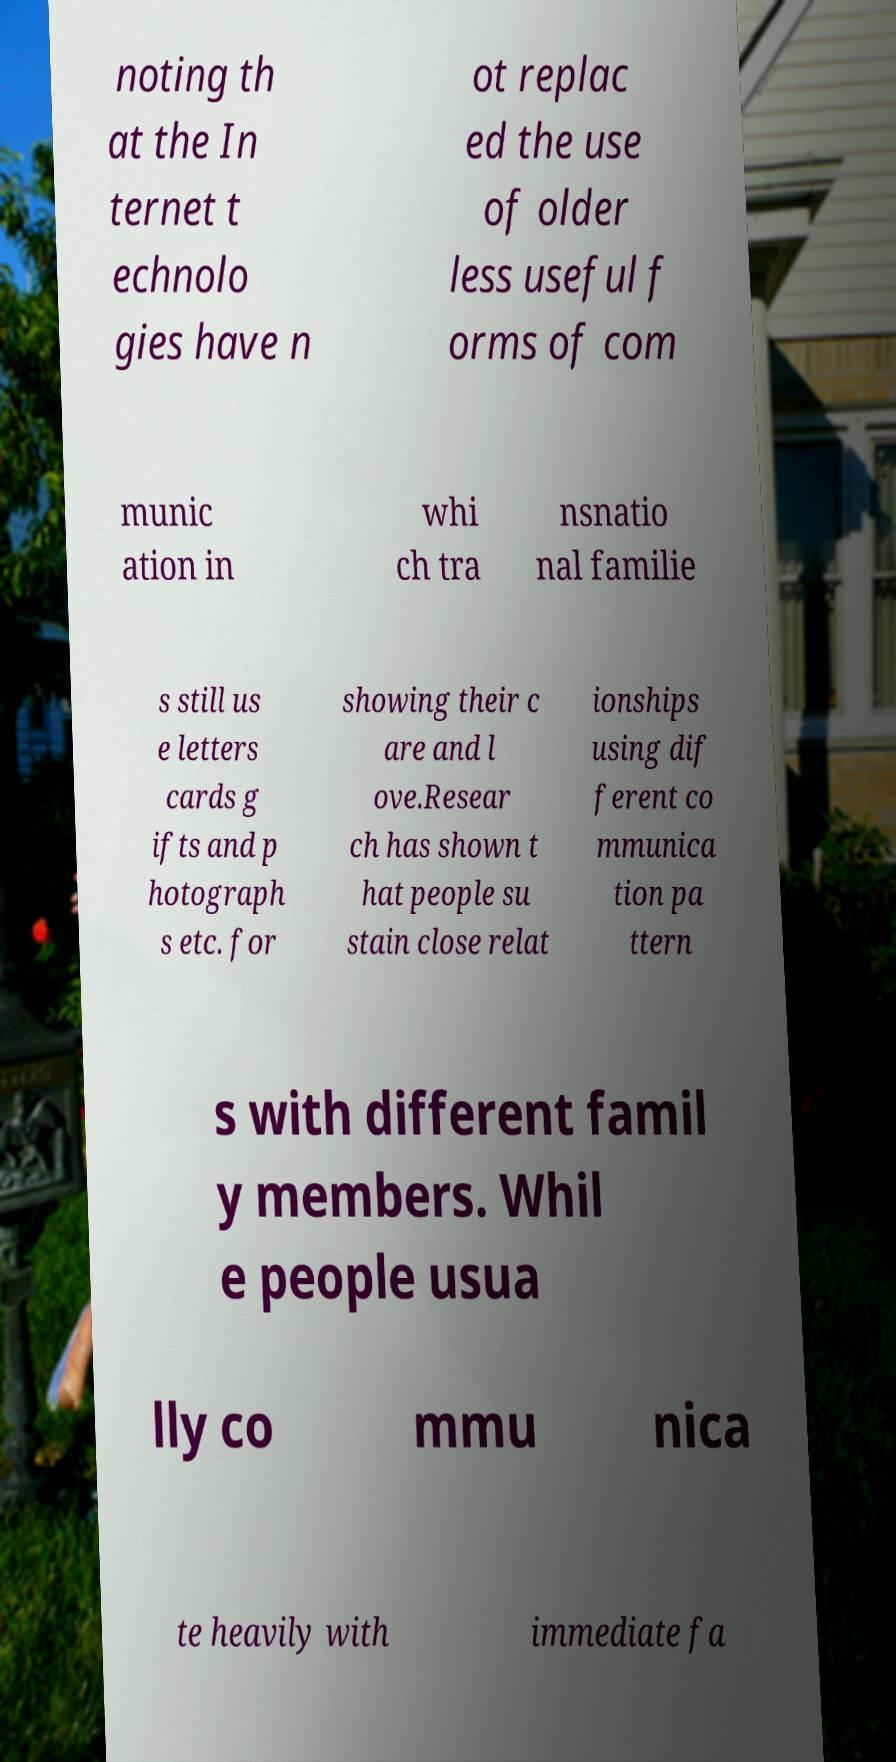For documentation purposes, I need the text within this image transcribed. Could you provide that? noting th at the In ternet t echnolo gies have n ot replac ed the use of older less useful f orms of com munic ation in whi ch tra nsnatio nal familie s still us e letters cards g ifts and p hotograph s etc. for showing their c are and l ove.Resear ch has shown t hat people su stain close relat ionships using dif ferent co mmunica tion pa ttern s with different famil y members. Whil e people usua lly co mmu nica te heavily with immediate fa 